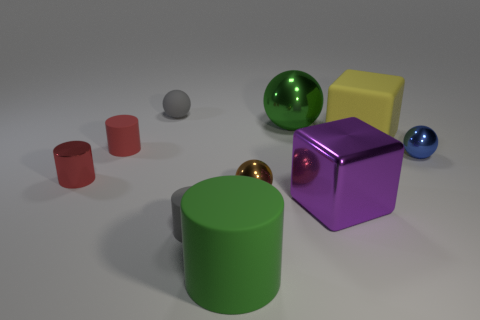Does the tiny gray ball have the same material as the green object that is behind the large purple cube?
Your response must be concise. No. Is the number of red things that are in front of the tiny blue ball the same as the number of big purple blocks in front of the large purple shiny cube?
Your answer should be compact. No. What is the large yellow block made of?
Offer a terse response. Rubber. The shiny cube that is the same size as the green cylinder is what color?
Make the answer very short. Purple. Is there a ball that is in front of the large matte thing in front of the big yellow thing?
Keep it short and to the point. No. What number of spheres are red things or large purple objects?
Provide a succinct answer. 0. How big is the brown metallic object that is right of the gray thing that is behind the large green thing that is behind the blue object?
Offer a very short reply. Small. There is a matte sphere; are there any things right of it?
Provide a short and direct response. Yes. There is a shiny object that is the same color as the large matte cylinder; what shape is it?
Give a very brief answer. Sphere. How many things are tiny cylinders in front of the small brown metal sphere or metallic balls?
Provide a short and direct response. 4. 